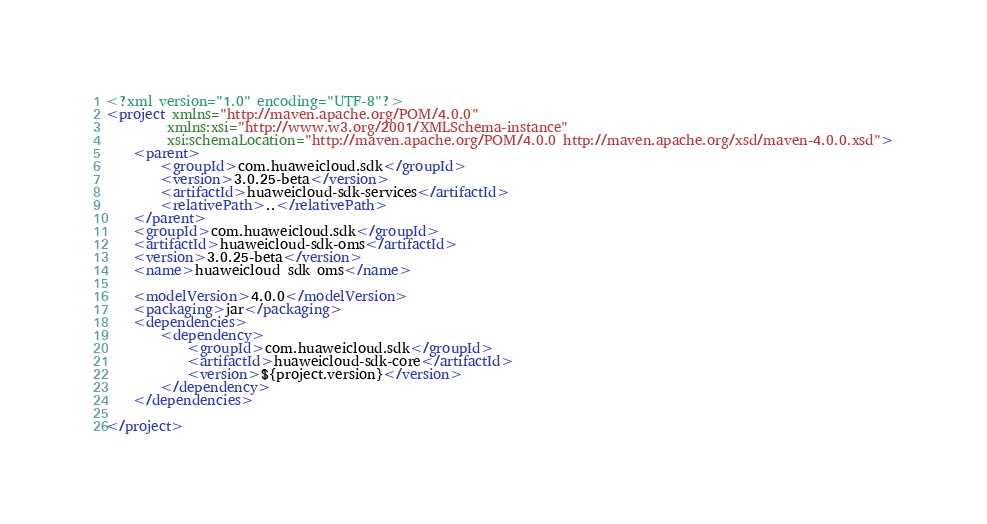Convert code to text. <code><loc_0><loc_0><loc_500><loc_500><_XML_><?xml version="1.0" encoding="UTF-8"?>
<project xmlns="http://maven.apache.org/POM/4.0.0"
         xmlns:xsi="http://www.w3.org/2001/XMLSchema-instance"
         xsi:schemaLocation="http://maven.apache.org/POM/4.0.0 http://maven.apache.org/xsd/maven-4.0.0.xsd">
    <parent>
        <groupId>com.huaweicloud.sdk</groupId>
        <version>3.0.25-beta</version>
        <artifactId>huaweicloud-sdk-services</artifactId>
        <relativePath>..</relativePath>
    </parent>
    <groupId>com.huaweicloud.sdk</groupId>
    <artifactId>huaweicloud-sdk-oms</artifactId>
    <version>3.0.25-beta</version>
    <name>huaweicloud sdk oms</name>

    <modelVersion>4.0.0</modelVersion>
    <packaging>jar</packaging>
    <dependencies>
        <dependency>
            <groupId>com.huaweicloud.sdk</groupId>
            <artifactId>huaweicloud-sdk-core</artifactId>
            <version>${project.version}</version>
        </dependency>
    </dependencies>

</project></code> 